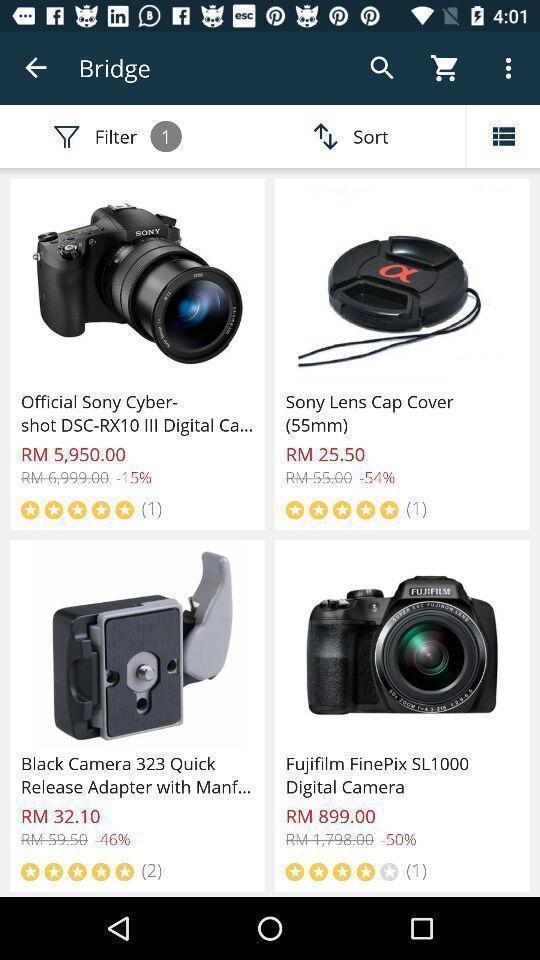Describe the content in this image. Page shows list of a cameras in a shopping app. 